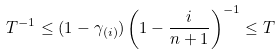Convert formula to latex. <formula><loc_0><loc_0><loc_500><loc_500>T ^ { - 1 } \leq ( 1 - \gamma _ { ( i ) } ) \left ( 1 - \frac { i } { n + 1 } \right ) ^ { - 1 } \leq T</formula> 